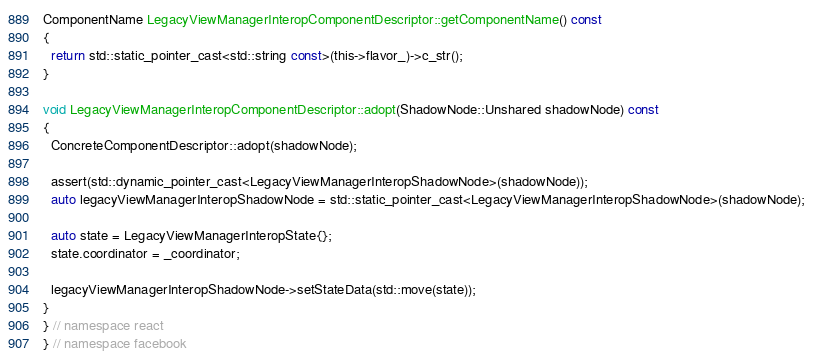<code> <loc_0><loc_0><loc_500><loc_500><_ObjectiveC_>
ComponentName LegacyViewManagerInteropComponentDescriptor::getComponentName() const
{
  return std::static_pointer_cast<std::string const>(this->flavor_)->c_str();
}

void LegacyViewManagerInteropComponentDescriptor::adopt(ShadowNode::Unshared shadowNode) const
{
  ConcreteComponentDescriptor::adopt(shadowNode);

  assert(std::dynamic_pointer_cast<LegacyViewManagerInteropShadowNode>(shadowNode));
  auto legacyViewManagerInteropShadowNode = std::static_pointer_cast<LegacyViewManagerInteropShadowNode>(shadowNode);

  auto state = LegacyViewManagerInteropState{};
  state.coordinator = _coordinator;

  legacyViewManagerInteropShadowNode->setStateData(std::move(state));
}
} // namespace react
} // namespace facebook
</code> 